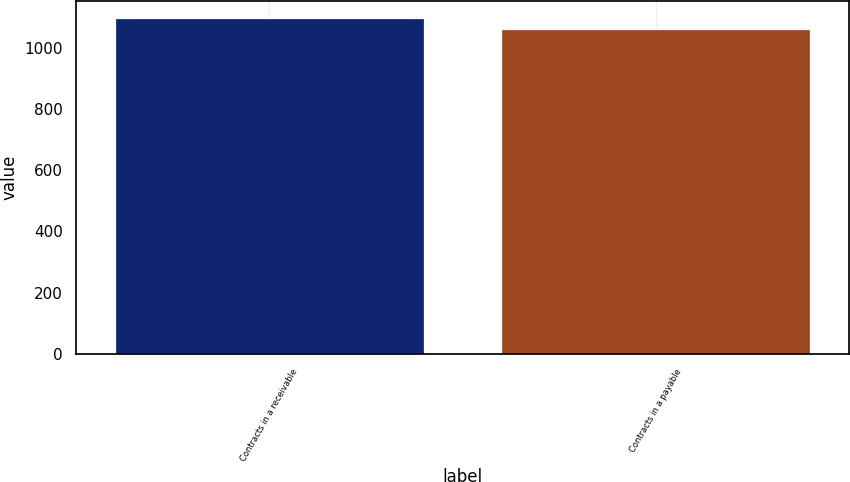Convert chart to OTSL. <chart><loc_0><loc_0><loc_500><loc_500><bar_chart><fcel>Contracts in a receivable<fcel>Contracts in a payable<nl><fcel>1098<fcel>1060<nl></chart> 